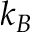<formula> <loc_0><loc_0><loc_500><loc_500>k _ { B }</formula> 